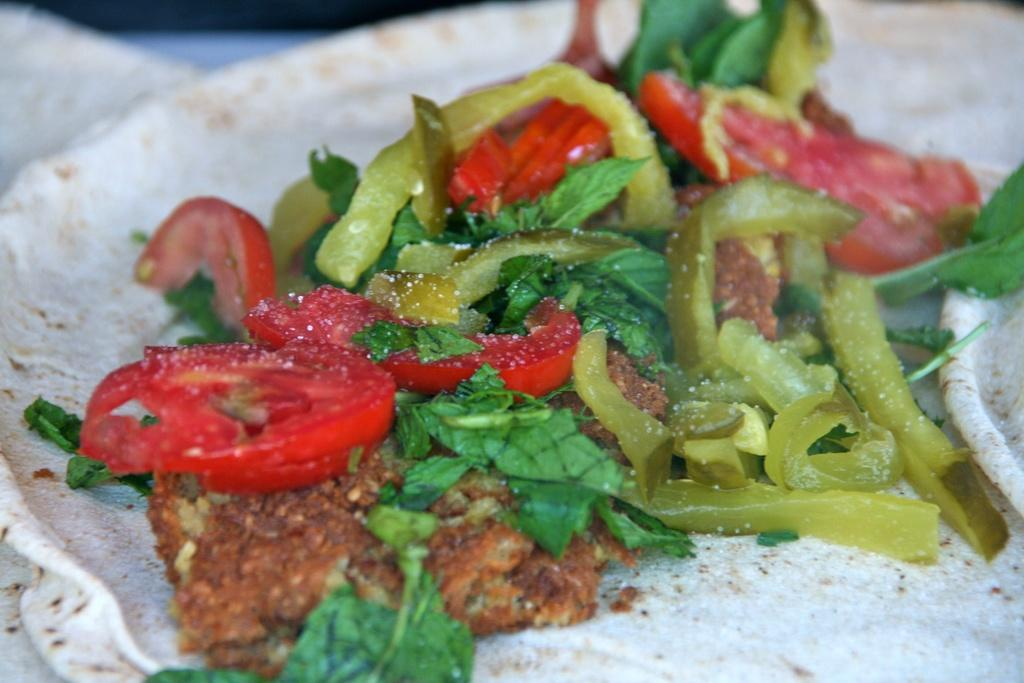What type of food is visible in the image? There are chapatis in the image. What is placed on top of the chapatis? There are tomato slices, capsicum slices, and leafy vegetables on the chapatis. Are there any other food items on the chapatis? Yes, there are other food items on the chapatis. What type of silverware is used to serve the food in the image? There is no silverware visible in the image; it only shows the chapatis with various toppings. Can you describe the furniture in the image? There is no furniture present in the image; it only shows the chapatis with various toppings. 